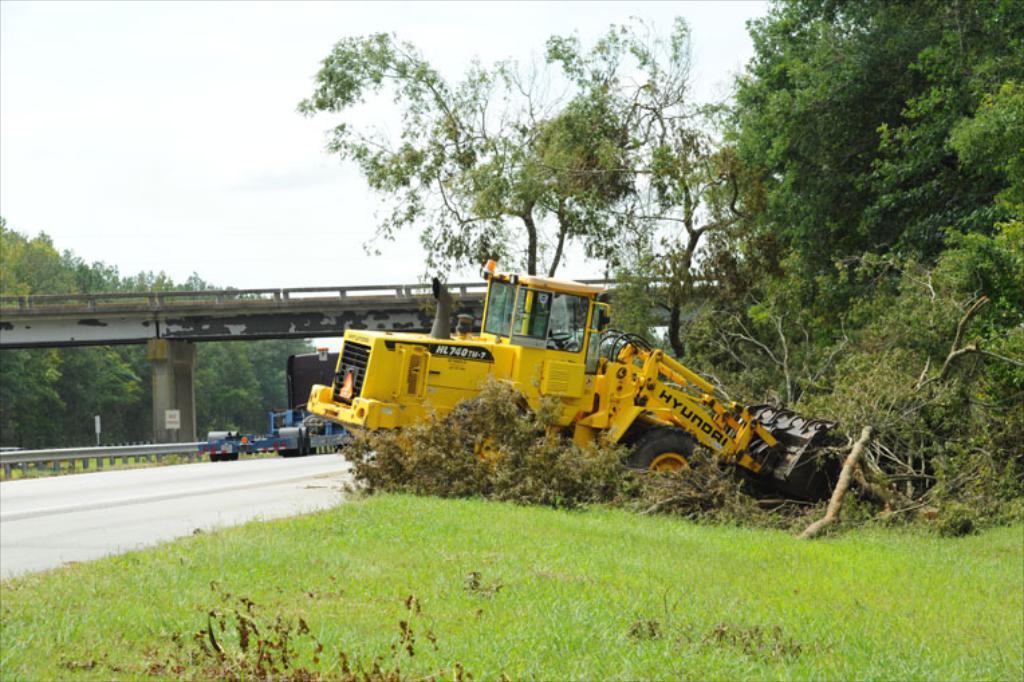Can you describe this image briefly? This is an outside view. In this image I can see bulldozer which is in yellow color. It is lifting the trees. At the bottom of the image I can see the grass in green color. On the left side that is a road. In the background, I can see a bridge and some trees. On the top of the image I can see the sky. 